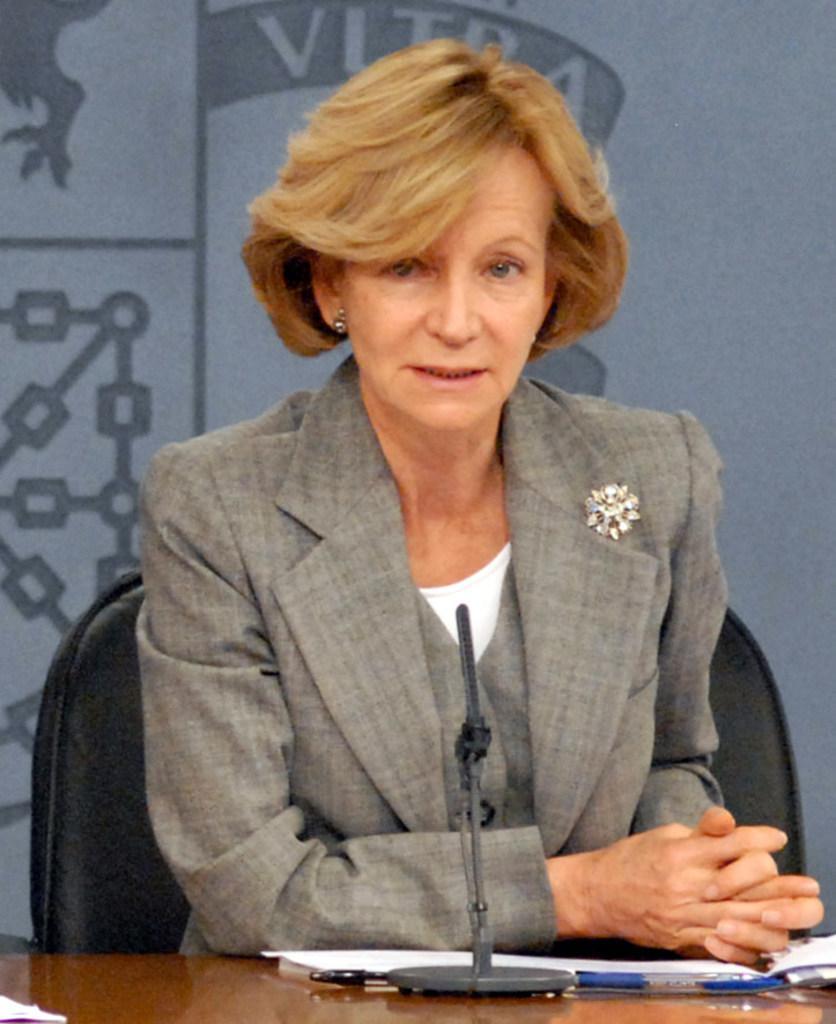Describe this image in one or two sentences. In this image I can see the person sitting on the chair and wearing the white and grey color dress. In-front of the person I can see the table. On the tape I can see the mic, pen and papers. And there is a ash and grey color background. 